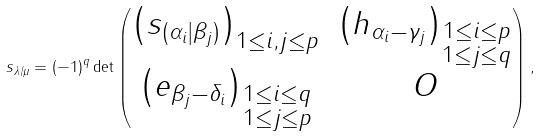Convert formula to latex. <formula><loc_0><loc_0><loc_500><loc_500>s _ { \lambda / \mu } = ( - 1 ) ^ { q } \det \begin{pmatrix} \left ( s _ { ( \alpha _ { i } | \beta _ { j } ) } \right ) _ { 1 \leq i , j \leq p } & \left ( h _ { \alpha _ { i } - \gamma _ { j } } \right ) _ { \substack { 1 \leq i \leq p \\ 1 \leq j \leq q } } \\ \left ( e _ { \beta _ { j } - \delta _ { i } } \right ) _ { \substack { 1 \leq i \leq q \\ 1 \leq j \leq p } } & O \end{pmatrix} ,</formula> 